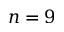<formula> <loc_0><loc_0><loc_500><loc_500>n = 9</formula> 